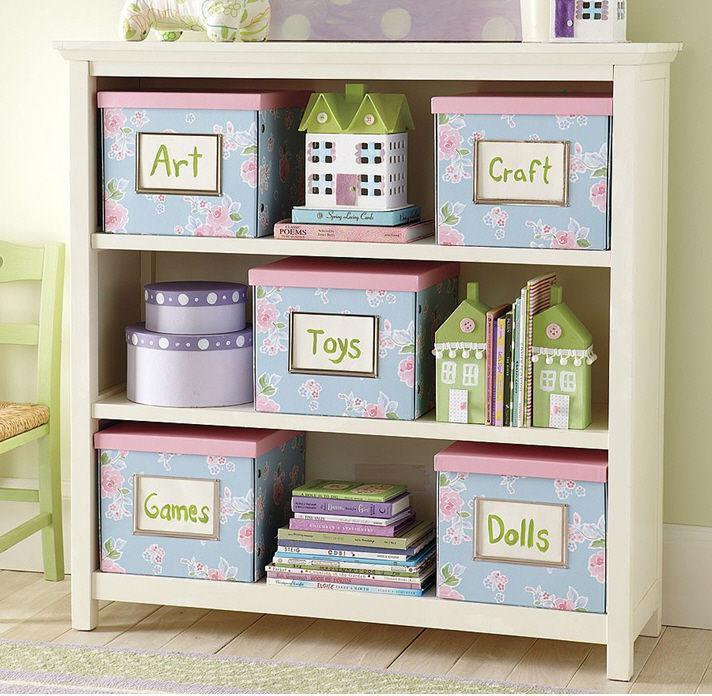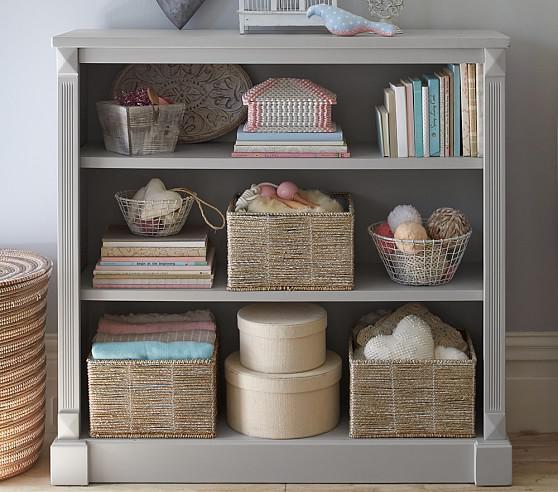The first image is the image on the left, the second image is the image on the right. Analyze the images presented: Is the assertion "Two shelf units, one on short legs and one flush with the floor, are different widths and have a different number of shelves." valid? Answer yes or no. No. The first image is the image on the left, the second image is the image on the right. Examine the images to the left and right. Is the description "One storage unit contains some blue bins with labels on the front, and the other holds several fiber-type baskets." accurate? Answer yes or no. Yes. 